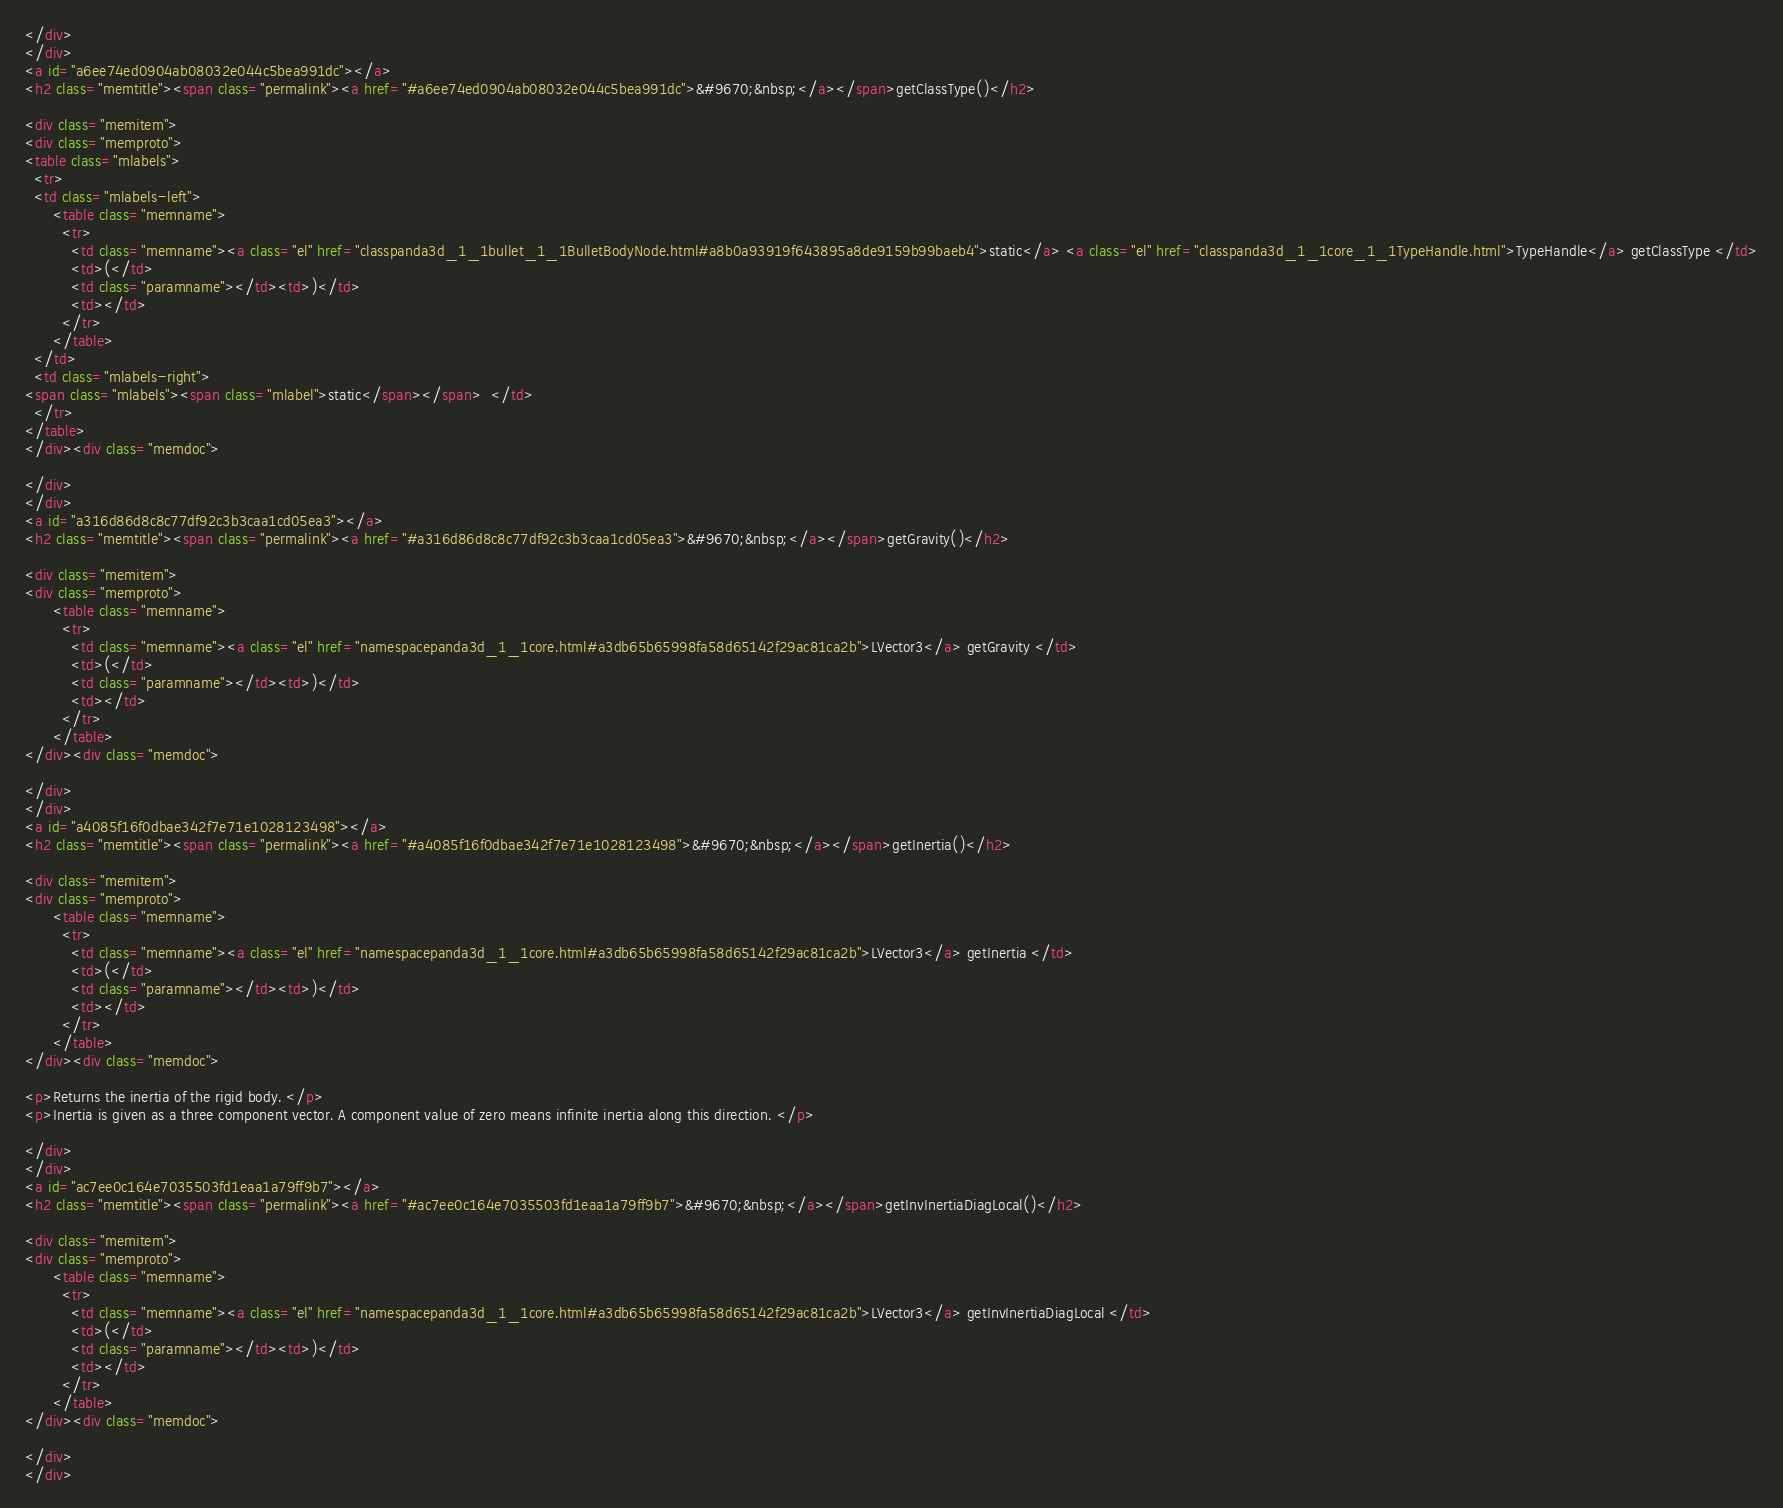Convert code to text. <code><loc_0><loc_0><loc_500><loc_500><_HTML_></div>
</div>
<a id="a6ee74ed0904ab08032e044c5bea991dc"></a>
<h2 class="memtitle"><span class="permalink"><a href="#a6ee74ed0904ab08032e044c5bea991dc">&#9670;&nbsp;</a></span>getClassType()</h2>

<div class="memitem">
<div class="memproto">
<table class="mlabels">
  <tr>
  <td class="mlabels-left">
      <table class="memname">
        <tr>
          <td class="memname"><a class="el" href="classpanda3d_1_1bullet_1_1BulletBodyNode.html#a8b0a93919f643895a8de9159b99baeb4">static</a> <a class="el" href="classpanda3d_1_1core_1_1TypeHandle.html">TypeHandle</a> getClassType </td>
          <td>(</td>
          <td class="paramname"></td><td>)</td>
          <td></td>
        </tr>
      </table>
  </td>
  <td class="mlabels-right">
<span class="mlabels"><span class="mlabel">static</span></span>  </td>
  </tr>
</table>
</div><div class="memdoc">

</div>
</div>
<a id="a316d86d8c8c77df92c3b3caa1cd05ea3"></a>
<h2 class="memtitle"><span class="permalink"><a href="#a316d86d8c8c77df92c3b3caa1cd05ea3">&#9670;&nbsp;</a></span>getGravity()</h2>

<div class="memitem">
<div class="memproto">
      <table class="memname">
        <tr>
          <td class="memname"><a class="el" href="namespacepanda3d_1_1core.html#a3db65b65998fa58d65142f29ac81ca2b">LVector3</a> getGravity </td>
          <td>(</td>
          <td class="paramname"></td><td>)</td>
          <td></td>
        </tr>
      </table>
</div><div class="memdoc">

</div>
</div>
<a id="a4085f16f0dbae342f7e71e1028123498"></a>
<h2 class="memtitle"><span class="permalink"><a href="#a4085f16f0dbae342f7e71e1028123498">&#9670;&nbsp;</a></span>getInertia()</h2>

<div class="memitem">
<div class="memproto">
      <table class="memname">
        <tr>
          <td class="memname"><a class="el" href="namespacepanda3d_1_1core.html#a3db65b65998fa58d65142f29ac81ca2b">LVector3</a> getInertia </td>
          <td>(</td>
          <td class="paramname"></td><td>)</td>
          <td></td>
        </tr>
      </table>
</div><div class="memdoc">

<p>Returns the inertia of the rigid body. </p>
<p>Inertia is given as a three component vector. A component value of zero means infinite inertia along this direction. </p>

</div>
</div>
<a id="ac7ee0c164e7035503fd1eaa1a79ff9b7"></a>
<h2 class="memtitle"><span class="permalink"><a href="#ac7ee0c164e7035503fd1eaa1a79ff9b7">&#9670;&nbsp;</a></span>getInvInertiaDiagLocal()</h2>

<div class="memitem">
<div class="memproto">
      <table class="memname">
        <tr>
          <td class="memname"><a class="el" href="namespacepanda3d_1_1core.html#a3db65b65998fa58d65142f29ac81ca2b">LVector3</a> getInvInertiaDiagLocal </td>
          <td>(</td>
          <td class="paramname"></td><td>)</td>
          <td></td>
        </tr>
      </table>
</div><div class="memdoc">

</div>
</div></code> 